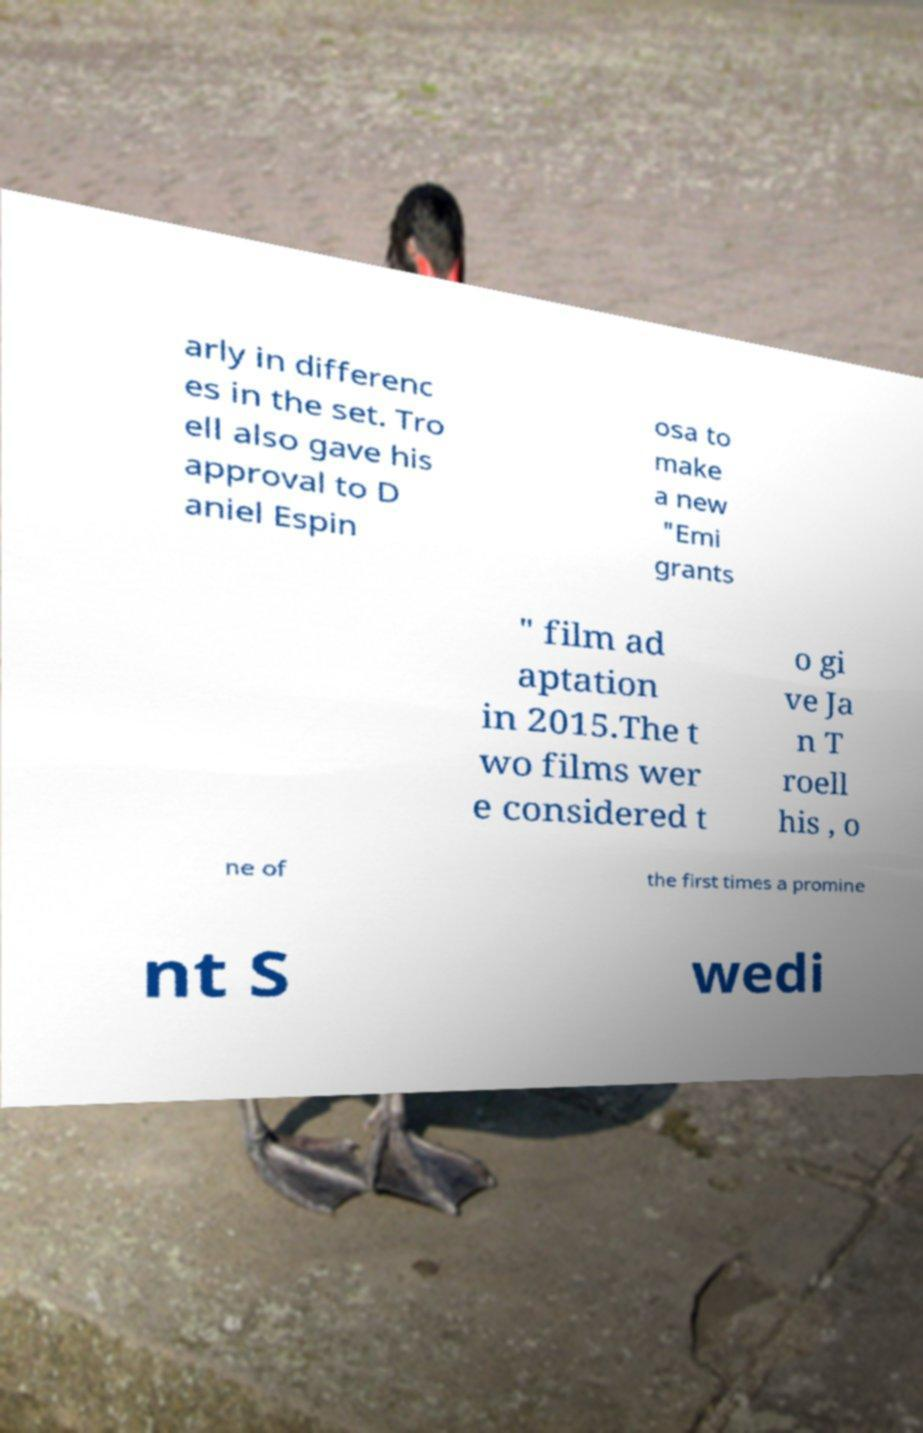Could you extract and type out the text from this image? arly in differenc es in the set. Tro ell also gave his approval to D aniel Espin osa to make a new "Emi grants " film ad aptation in 2015.The t wo films wer e considered t o gi ve Ja n T roell his , o ne of the first times a promine nt S wedi 